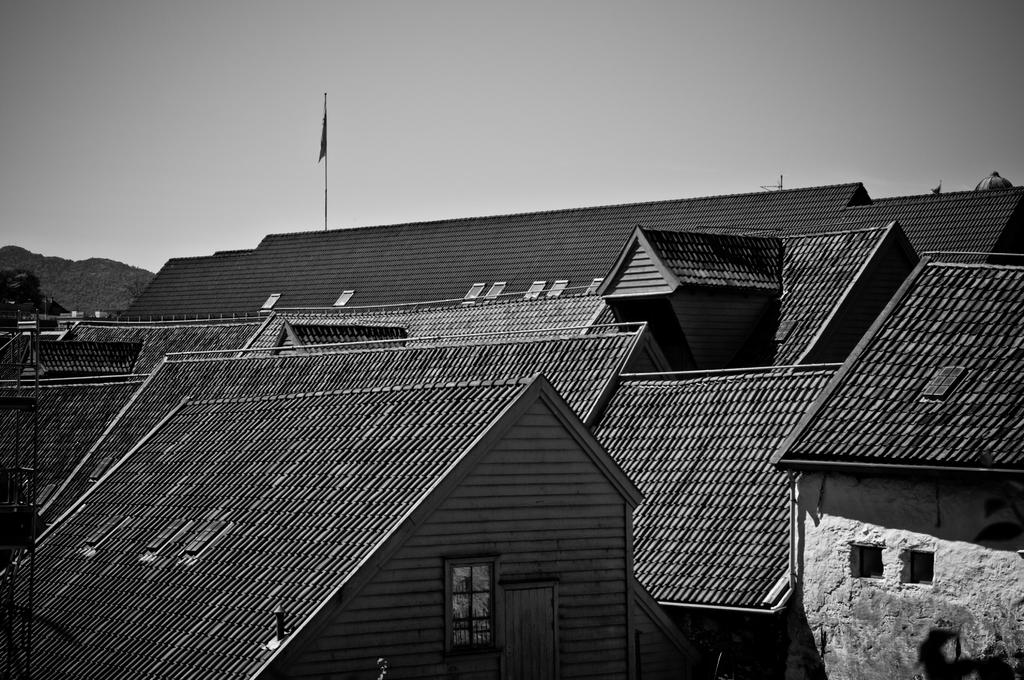What type of structures are present in the image? There is a group of buildings in the image. What can be seen on a pole in the image? There is a flag on a pole in the image. What is visible in the background of the image? The sky is visible in the background of the image. What type of ink is used to write on the calendar in the image? There is no calendar present in the image, so it is not possible to determine what type of ink might be used. 